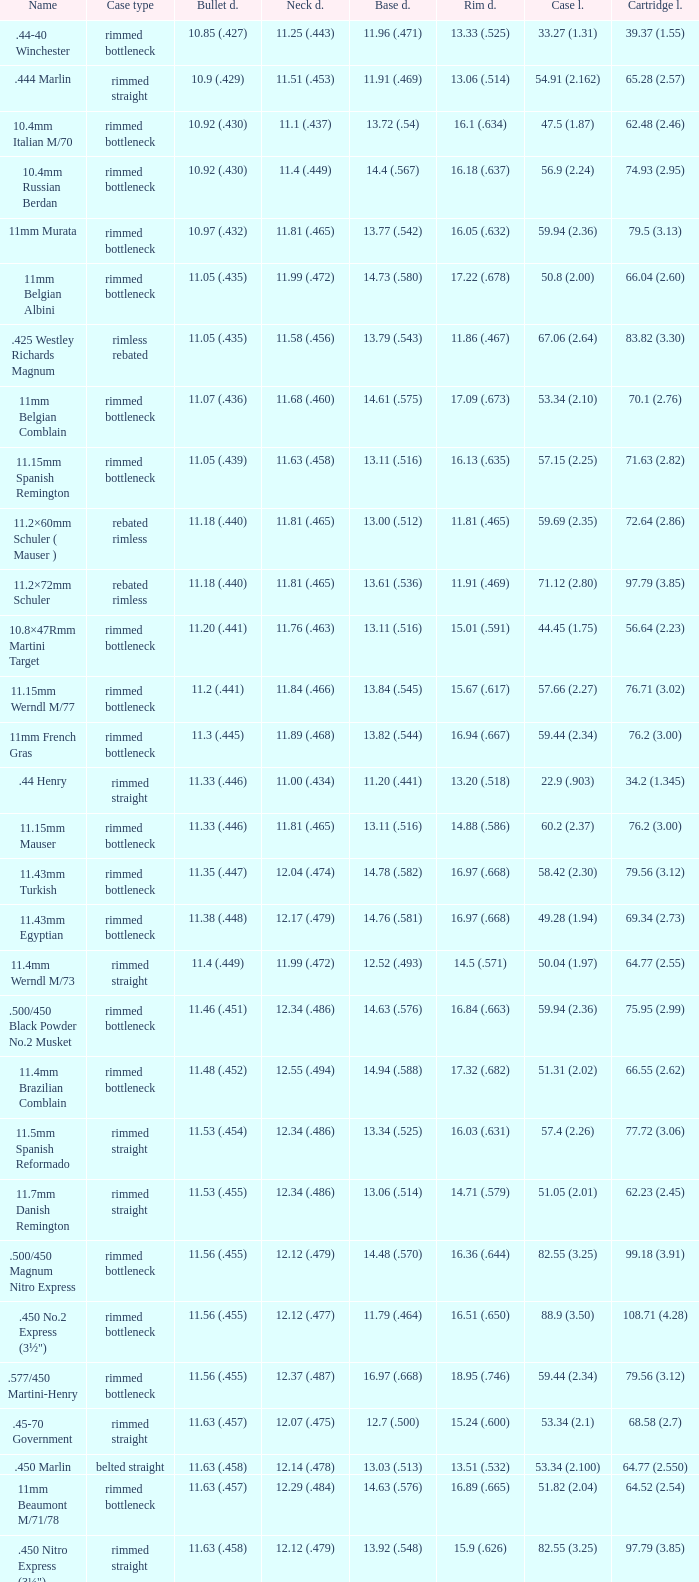Which Bullet diameter has a Neck diameter of 12.17 (.479)? 11.38 (.448). Can you parse all the data within this table? {'header': ['Name', 'Case type', 'Bullet d.', 'Neck d.', 'Base d.', 'Rim d.', 'Case l.', 'Cartridge l.'], 'rows': [['.44-40 Winchester', 'rimmed bottleneck', '10.85 (.427)', '11.25 (.443)', '11.96 (.471)', '13.33 (.525)', '33.27 (1.31)', '39.37 (1.55)'], ['.444 Marlin', 'rimmed straight', '10.9 (.429)', '11.51 (.453)', '11.91 (.469)', '13.06 (.514)', '54.91 (2.162)', '65.28 (2.57)'], ['10.4mm Italian M/70', 'rimmed bottleneck', '10.92 (.430)', '11.1 (.437)', '13.72 (.54)', '16.1 (.634)', '47.5 (1.87)', '62.48 (2.46)'], ['10.4mm Russian Berdan', 'rimmed bottleneck', '10.92 (.430)', '11.4 (.449)', '14.4 (.567)', '16.18 (.637)', '56.9 (2.24)', '74.93 (2.95)'], ['11mm Murata', 'rimmed bottleneck', '10.97 (.432)', '11.81 (.465)', '13.77 (.542)', '16.05 (.632)', '59.94 (2.36)', '79.5 (3.13)'], ['11mm Belgian Albini', 'rimmed bottleneck', '11.05 (.435)', '11.99 (.472)', '14.73 (.580)', '17.22 (.678)', '50.8 (2.00)', '66.04 (2.60)'], ['.425 Westley Richards Magnum', 'rimless rebated', '11.05 (.435)', '11.58 (.456)', '13.79 (.543)', '11.86 (.467)', '67.06 (2.64)', '83.82 (3.30)'], ['11mm Belgian Comblain', 'rimmed bottleneck', '11.07 (.436)', '11.68 (.460)', '14.61 (.575)', '17.09 (.673)', '53.34 (2.10)', '70.1 (2.76)'], ['11.15mm Spanish Remington', 'rimmed bottleneck', '11.05 (.439)', '11.63 (.458)', '13.11 (.516)', '16.13 (.635)', '57.15 (2.25)', '71.63 (2.82)'], ['11.2×60mm Schuler ( Mauser )', 'rebated rimless', '11.18 (.440)', '11.81 (.465)', '13.00 (.512)', '11.81 (.465)', '59.69 (2.35)', '72.64 (2.86)'], ['11.2×72mm Schuler', 'rebated rimless', '11.18 (.440)', '11.81 (.465)', '13.61 (.536)', '11.91 (.469)', '71.12 (2.80)', '97.79 (3.85)'], ['10.8×47Rmm Martini Target', 'rimmed bottleneck', '11.20 (.441)', '11.76 (.463)', '13.11 (.516)', '15.01 (.591)', '44.45 (1.75)', '56.64 (2.23)'], ['11.15mm Werndl M/77', 'rimmed bottleneck', '11.2 (.441)', '11.84 (.466)', '13.84 (.545)', '15.67 (.617)', '57.66 (2.27)', '76.71 (3.02)'], ['11mm French Gras', 'rimmed bottleneck', '11.3 (.445)', '11.89 (.468)', '13.82 (.544)', '16.94 (.667)', '59.44 (2.34)', '76.2 (3.00)'], ['.44 Henry', 'rimmed straight', '11.33 (.446)', '11.00 (.434)', '11.20 (.441)', '13.20 (.518)', '22.9 (.903)', '34.2 (1.345)'], ['11.15mm Mauser', 'rimmed bottleneck', '11.33 (.446)', '11.81 (.465)', '13.11 (.516)', '14.88 (.586)', '60.2 (2.37)', '76.2 (3.00)'], ['11.43mm Turkish', 'rimmed bottleneck', '11.35 (.447)', '12.04 (.474)', '14.78 (.582)', '16.97 (.668)', '58.42 (2.30)', '79.56 (3.12)'], ['11.43mm Egyptian', 'rimmed bottleneck', '11.38 (.448)', '12.17 (.479)', '14.76 (.581)', '16.97 (.668)', '49.28 (1.94)', '69.34 (2.73)'], ['11.4mm Werndl M/73', 'rimmed straight', '11.4 (.449)', '11.99 (.472)', '12.52 (.493)', '14.5 (.571)', '50.04 (1.97)', '64.77 (2.55)'], ['.500/450 Black Powder No.2 Musket', 'rimmed bottleneck', '11.46 (.451)', '12.34 (.486)', '14.63 (.576)', '16.84 (.663)', '59.94 (2.36)', '75.95 (2.99)'], ['11.4mm Brazilian Comblain', 'rimmed bottleneck', '11.48 (.452)', '12.55 (.494)', '14.94 (.588)', '17.32 (.682)', '51.31 (2.02)', '66.55 (2.62)'], ['11.5mm Spanish Reformado', 'rimmed straight', '11.53 (.454)', '12.34 (.486)', '13.34 (.525)', '16.03 (.631)', '57.4 (2.26)', '77.72 (3.06)'], ['11.7mm Danish Remington', 'rimmed straight', '11.53 (.455)', '12.34 (.486)', '13.06 (.514)', '14.71 (.579)', '51.05 (2.01)', '62.23 (2.45)'], ['.500/450 Magnum Nitro Express', 'rimmed bottleneck', '11.56 (.455)', '12.12 (.479)', '14.48 (.570)', '16.36 (.644)', '82.55 (3.25)', '99.18 (3.91)'], ['.450 No.2 Express (3½")', 'rimmed bottleneck', '11.56 (.455)', '12.12 (.477)', '11.79 (.464)', '16.51 (.650)', '88.9 (3.50)', '108.71 (4.28)'], ['.577/450 Martini-Henry', 'rimmed bottleneck', '11.56 (.455)', '12.37 (.487)', '16.97 (.668)', '18.95 (.746)', '59.44 (2.34)', '79.56 (3.12)'], ['.45-70 Government', 'rimmed straight', '11.63 (.457)', '12.07 (.475)', '12.7 (.500)', '15.24 (.600)', '53.34 (2.1)', '68.58 (2.7)'], ['.450 Marlin', 'belted straight', '11.63 (.458)', '12.14 (.478)', '13.03 (.513)', '13.51 (.532)', '53.34 (2.100)', '64.77 (2.550)'], ['11mm Beaumont M/71/78', 'rimmed bottleneck', '11.63 (.457)', '12.29 (.484)', '14.63 (.576)', '16.89 (.665)', '51.82 (2.04)', '64.52 (2.54)'], ['.450 Nitro Express (3¼")', 'rimmed straight', '11.63 (.458)', '12.12 (.479)', '13.92 (.548)', '15.9 (.626)', '82.55 (3.25)', '97.79 (3.85)'], ['.458 Winchester Magnum', 'belted straight', '11.63 (.458)', '12.14 (.478)', '13.03 (.513)', '13.51 (.532)', '63.5 (2.5)', '82.55 (3.350)'], ['.460 Weatherby Magnum', 'belted bottleneck', '11.63 (.458)', '12.32 (.485)', '14.80 (.583)', '13.54 (.533)', '74 (2.91)', '95.25 (3.75)'], ['.500/450 No.1 Express', 'rimmed bottleneck', '11.63 (.458)', '12.32 (.485)', '14.66 (.577)', '16.76 (.660)', '69.85 (2.75)', '82.55 (3.25)'], ['.450 Rigby Rimless', 'rimless bottleneck', '11.63 (.458)', '12.38 (.487)', '14.66 (.577)', '14.99 (.590)', '73.50 (2.89)', '95.00 (3.74)'], ['11.3mm Beaumont M/71', 'rimmed bottleneck', '11.63 (.464)', '12.34 (.486)', '14.76 (.581)', '16.92 (.666)', '50.04 (1.97)', '63.25 (2.49)'], ['.500/465 Nitro Express', 'rimmed bottleneck', '11.84 (.466)', '12.39 (.488)', '14.55 (.573)', '16.51 (.650)', '82.3 (3.24)', '98.04 (3.89)']]} 